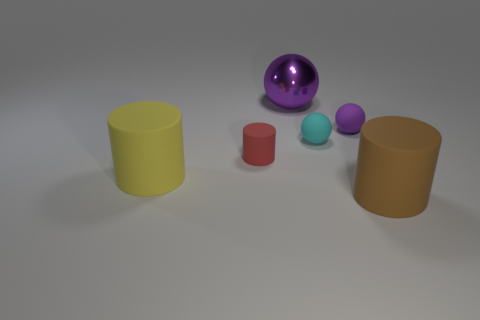How many other objects are there of the same size as the red cylinder?
Offer a terse response. 2. Is there a cyan metallic object that has the same shape as the big yellow thing?
Offer a very short reply. No. There is a small rubber object on the left side of the purple metallic ball; is its shape the same as the large matte thing left of the big brown matte cylinder?
Your response must be concise. Yes. Is there a red matte thing of the same size as the red cylinder?
Provide a short and direct response. No. Is the number of small red rubber objects that are behind the small red matte object the same as the number of brown objects that are behind the cyan matte thing?
Keep it short and to the point. Yes. Is the red cylinder that is in front of the tiny cyan matte sphere made of the same material as the thing to the left of the red cylinder?
Give a very brief answer. Yes. What material is the large brown thing?
Provide a succinct answer. Rubber. How many other things are the same color as the small cylinder?
Keep it short and to the point. 0. Is the large metallic object the same color as the tiny rubber cylinder?
Provide a succinct answer. No. What number of small brown matte cylinders are there?
Keep it short and to the point. 0. 